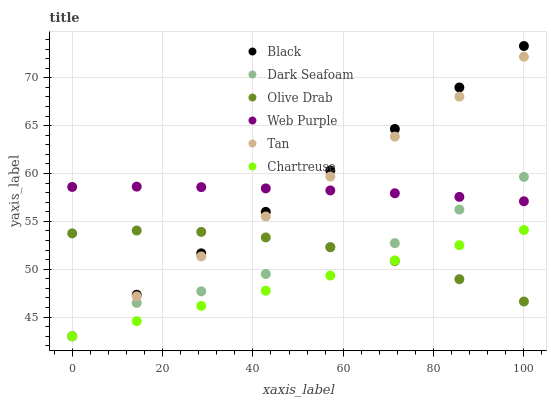Does Chartreuse have the minimum area under the curve?
Answer yes or no. Yes. Does Web Purple have the maximum area under the curve?
Answer yes or no. Yes. Does Dark Seafoam have the minimum area under the curve?
Answer yes or no. No. Does Dark Seafoam have the maximum area under the curve?
Answer yes or no. No. Is Tan the smoothest?
Answer yes or no. Yes. Is Dark Seafoam the roughest?
Answer yes or no. Yes. Is Black the smoothest?
Answer yes or no. No. Is Black the roughest?
Answer yes or no. No. Does Dark Seafoam have the lowest value?
Answer yes or no. Yes. Does Olive Drab have the lowest value?
Answer yes or no. No. Does Black have the highest value?
Answer yes or no. Yes. Does Dark Seafoam have the highest value?
Answer yes or no. No. Is Chartreuse less than Web Purple?
Answer yes or no. Yes. Is Web Purple greater than Chartreuse?
Answer yes or no. Yes. Does Chartreuse intersect Dark Seafoam?
Answer yes or no. Yes. Is Chartreuse less than Dark Seafoam?
Answer yes or no. No. Is Chartreuse greater than Dark Seafoam?
Answer yes or no. No. Does Chartreuse intersect Web Purple?
Answer yes or no. No. 